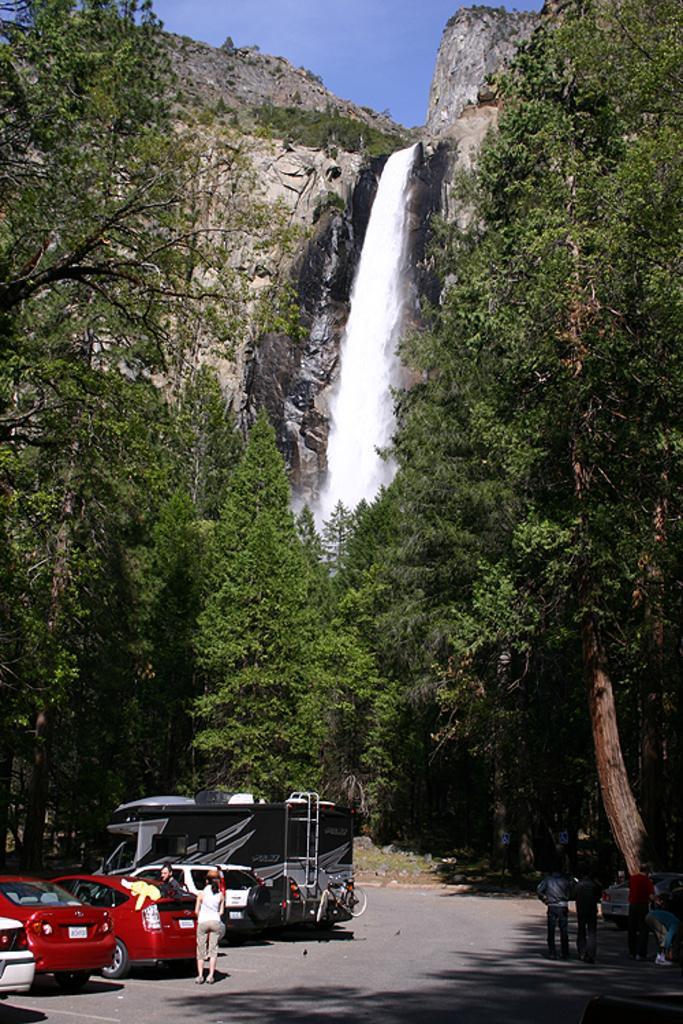How would you summarize this image in a sentence or two? In this image at the bottom we can see some vehicles, people and we can see some trees on either side of the road and in the middle we can see waterfall and in the background we can see the sky. 